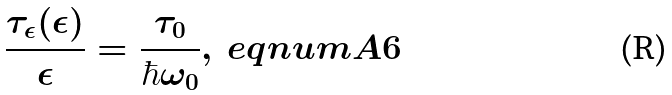Convert formula to latex. <formula><loc_0><loc_0><loc_500><loc_500>\frac { \tau _ { \epsilon } ( \epsilon ) } { \epsilon } = \frac { \tau _ { 0 } } { \hbar { \omega } _ { 0 } } , \ e q n u m { A 6 }</formula> 